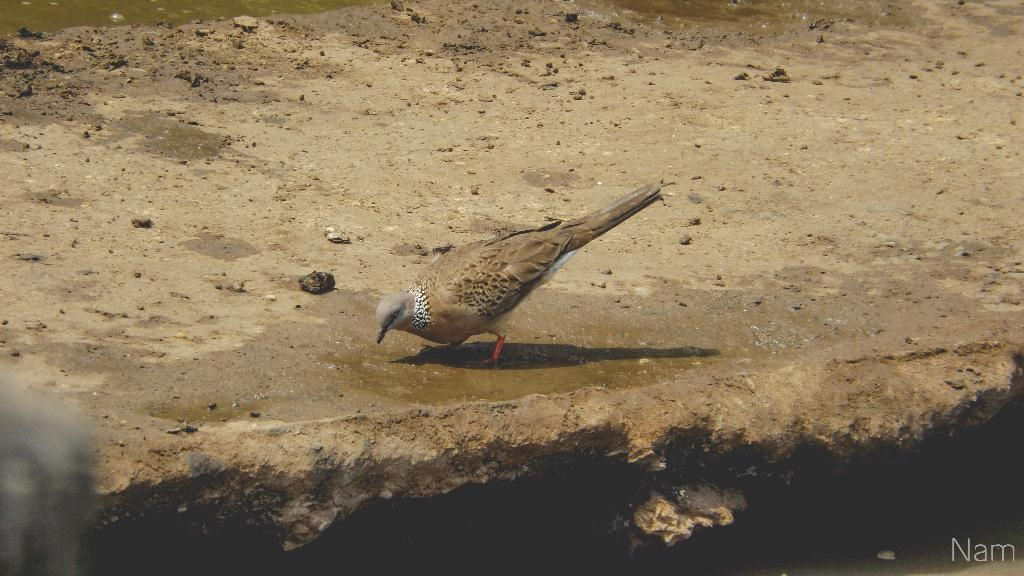What type of animal is present in the picture? There is a pigeon in the picture. What type of surface is visible in the picture? There is soil in the picture. Is there any liquid visible on the floor in the picture? Yes, there is water on the floor in the picture. Where can the watermark be found in the image? The watermark is located at the right side bottom of the image. What statement does the pigeon make in the image? The pigeon does not make any statements in the image, as it is a bird and cannot speak. 